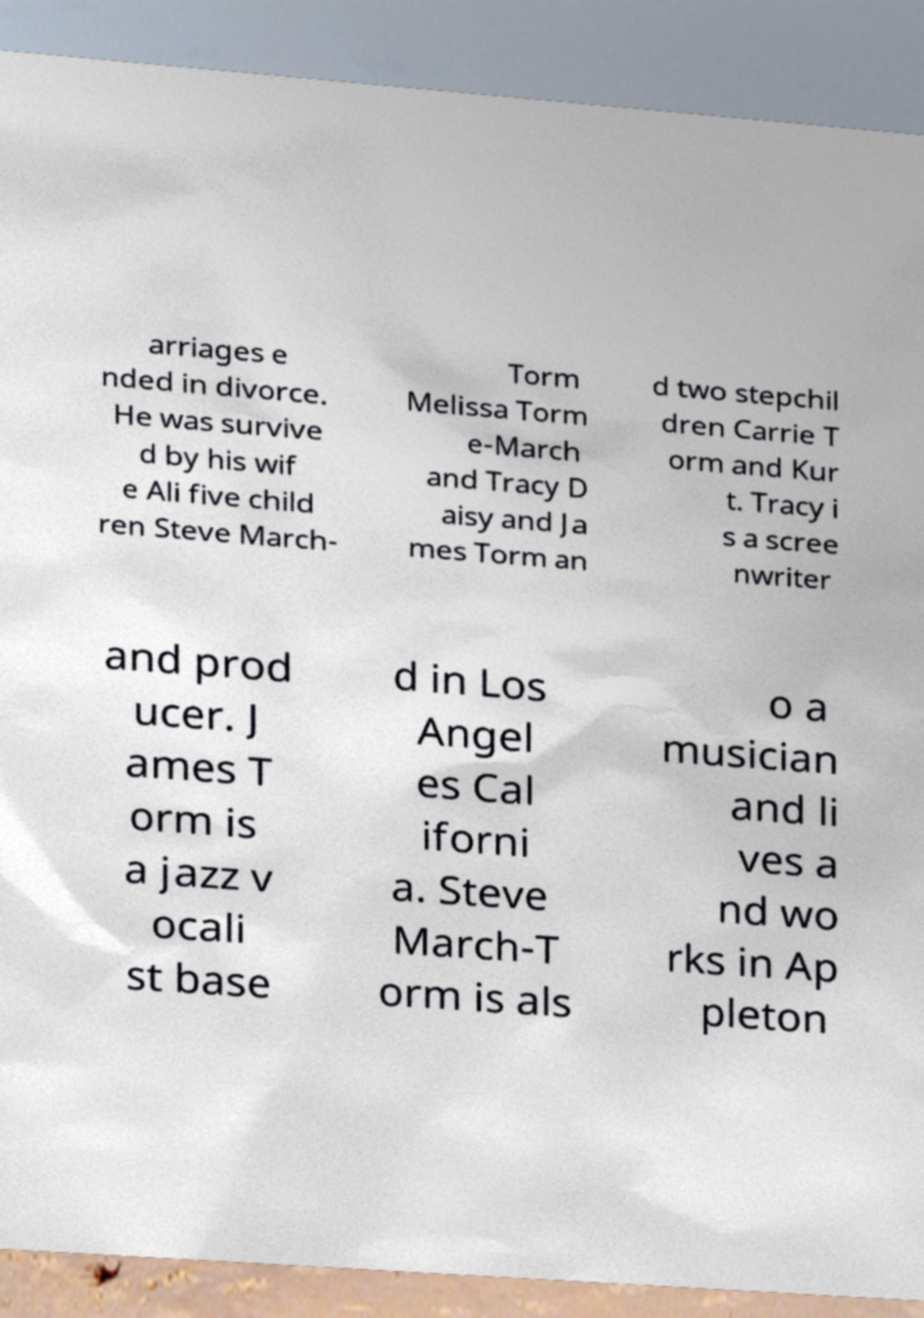Please read and relay the text visible in this image. What does it say? arriages e nded in divorce. He was survive d by his wif e Ali five child ren Steve March- Torm Melissa Torm e-March and Tracy D aisy and Ja mes Torm an d two stepchil dren Carrie T orm and Kur t. Tracy i s a scree nwriter and prod ucer. J ames T orm is a jazz v ocali st base d in Los Angel es Cal iforni a. Steve March-T orm is als o a musician and li ves a nd wo rks in Ap pleton 